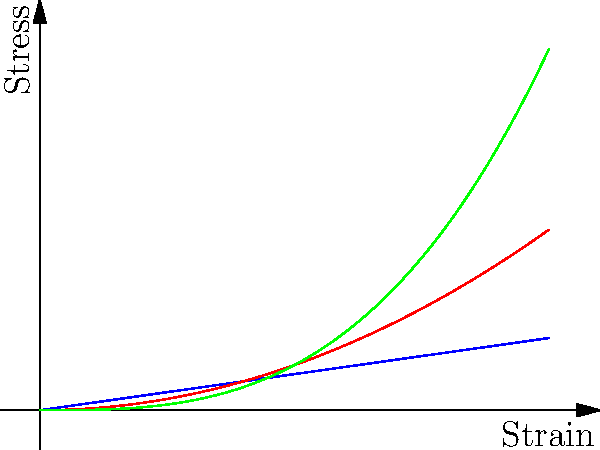As an industrial psychologist studying organizational behaviors in tech startups, you're analyzing the impact of material choices on product development timelines. Given the stress-strain curves for three different materials (A, B, and C) used in a startup's prototype, which material exhibits linear elastic behavior throughout the entire range shown? To determine which material exhibits linear elastic behavior throughout the entire range, we need to analyze the stress-strain curves for each material:

1. Material A (blue line):
   - The curve is a straight line.
   - It follows the equation $y = mx$, where $m$ is constant.
   - This indicates a constant relationship between stress and strain.

2. Material B (red line):
   - The curve is parabolic, following the equation $y = ax^2$.
   - The slope of the curve changes with increasing strain.
   - This indicates non-linear behavior.

3. Material C (green line):
   - The curve is cubic, following the equation $y = bx^3$.
   - The slope of the curve changes more rapidly with increasing strain.
   - This also indicates non-linear behavior.

Linear elastic behavior is characterized by a constant relationship between stress and strain, represented by a straight line on a stress-strain curve. This relationship is described by Hooke's Law: $\sigma = E\epsilon$, where $\sigma$ is stress, $E$ is Young's modulus, and $\epsilon$ is strain.

Among the three materials, only Material A exhibits a straight line throughout the entire range, indicating linear elastic behavior.
Answer: Material A 